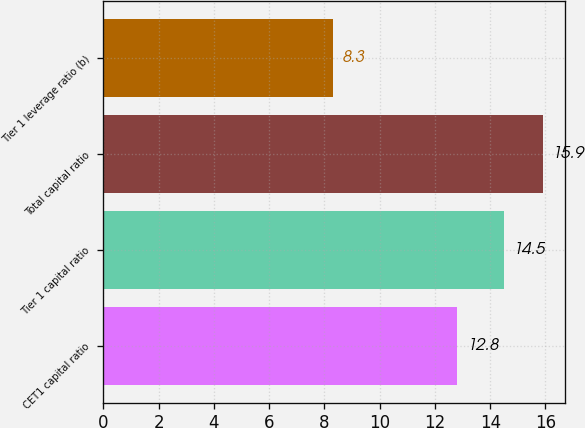Convert chart to OTSL. <chart><loc_0><loc_0><loc_500><loc_500><bar_chart><fcel>CET1 capital ratio<fcel>Tier 1 capital ratio<fcel>Total capital ratio<fcel>Tier 1 leverage ratio (b)<nl><fcel>12.8<fcel>14.5<fcel>15.9<fcel>8.3<nl></chart> 